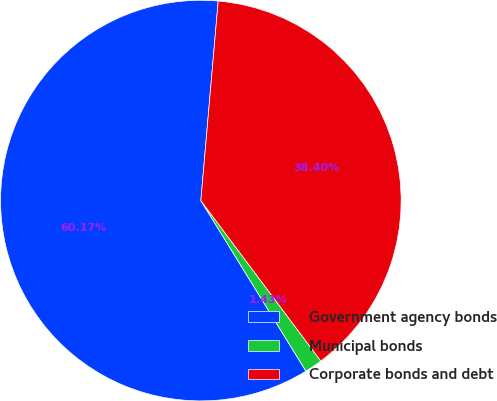<chart> <loc_0><loc_0><loc_500><loc_500><pie_chart><fcel>Government agency bonds<fcel>Municipal bonds<fcel>Corporate bonds and debt<nl><fcel>60.17%<fcel>1.43%<fcel>38.4%<nl></chart> 